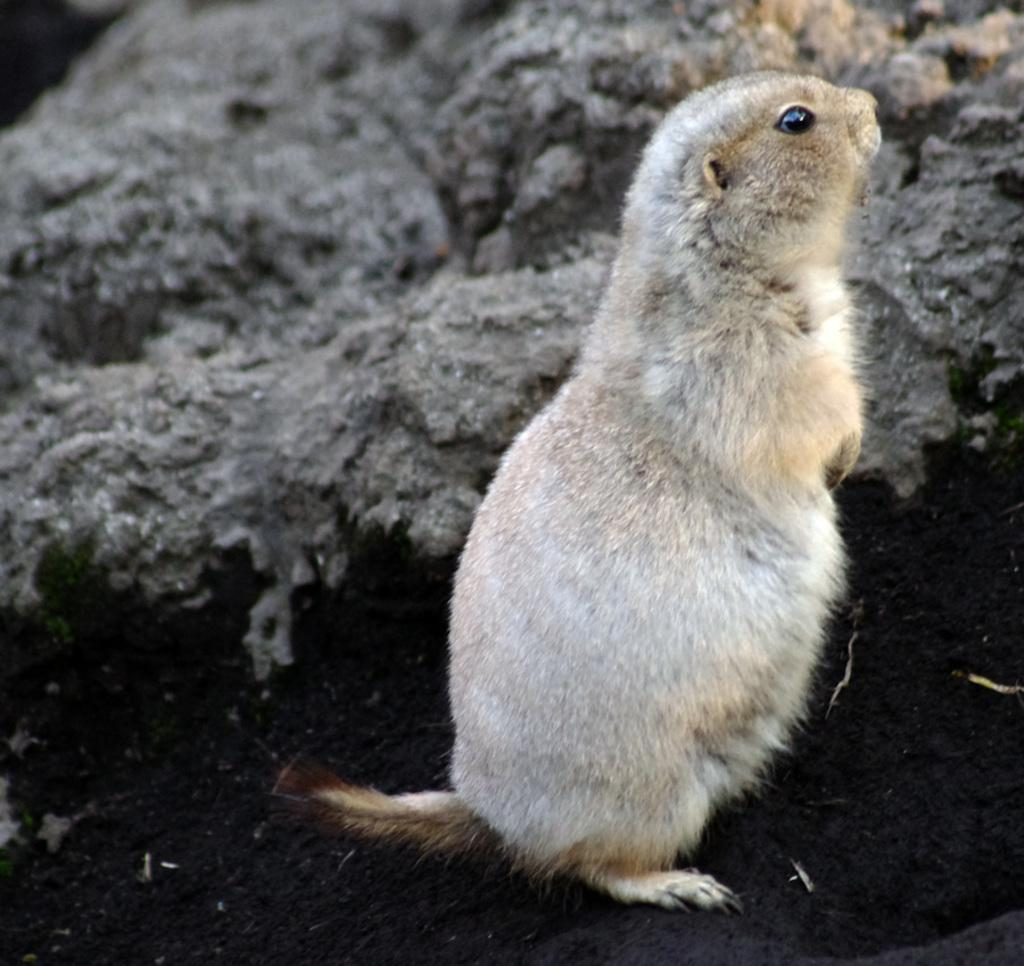What type of animal is present in the image? There is a rat in the image. What other object can be seen in the image? There is a rock in the image. Where is the baby located in the image? There is no baby present in the image; it only features a rat and a rock. What is the distribution of the rock in the image? The rock is a single object in the image and does not have a distribution. 